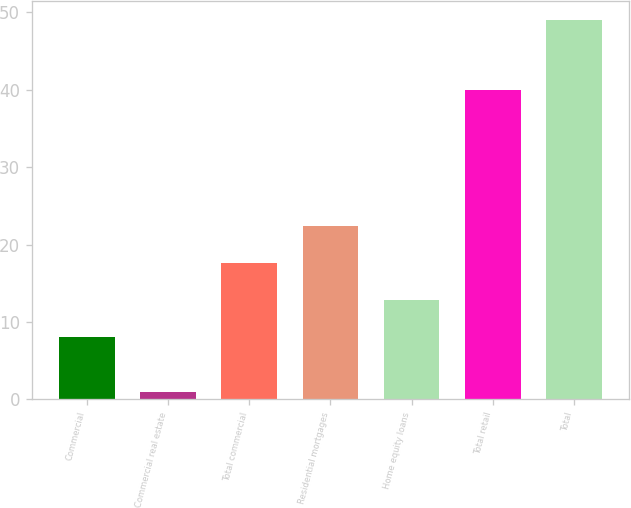Convert chart. <chart><loc_0><loc_0><loc_500><loc_500><bar_chart><fcel>Commercial<fcel>Commercial real estate<fcel>Total commercial<fcel>Residential mortgages<fcel>Home equity loans<fcel>Total retail<fcel>Total<nl><fcel>8<fcel>1<fcel>17.6<fcel>22.4<fcel>12.8<fcel>40<fcel>49<nl></chart> 